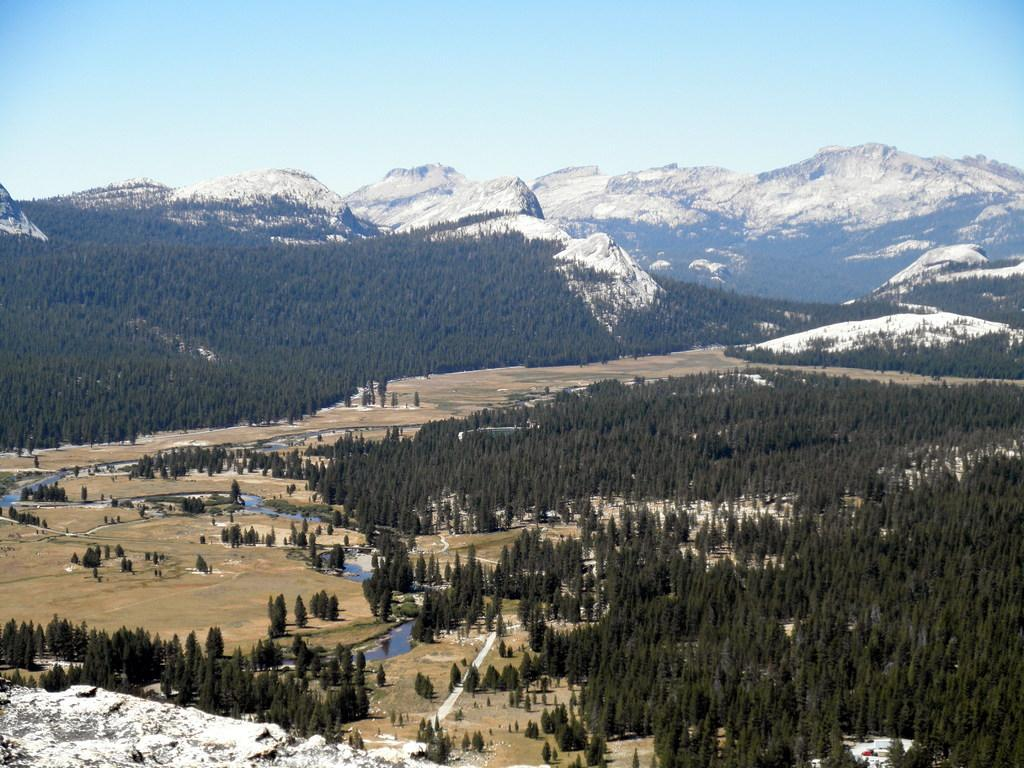What type of vegetation can be seen in the image? There are trees in the image. What natural feature is visible in the background of the image? There are mountains in the background of the image. What color is the sky in the image? The sky is blue in color. What type of blade is being used to cut the dinner in the image? There is no dinner or blade present in the image. Are there any police officers visible in the image? There are no police officers present in the image. 